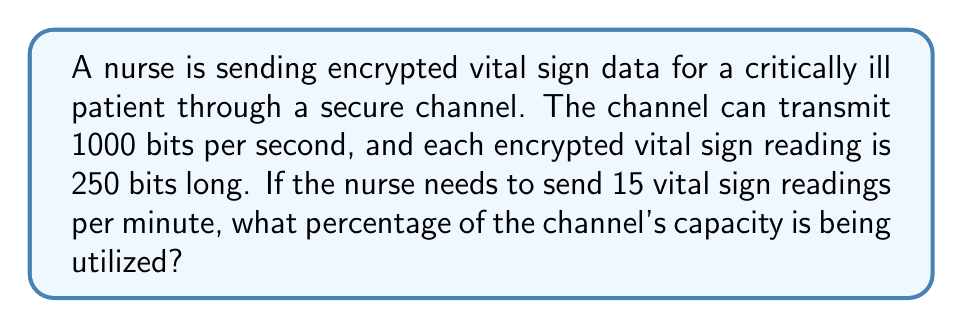Solve this math problem. Let's approach this step-by-step:

1. Calculate the number of bits transmitted per minute:
   - Each vital sign reading is 250 bits
   - 15 readings are sent per minute
   - Total bits per minute = $15 \times 250 = 3750$ bits/minute

2. Convert the channel capacity to bits per minute:
   - Channel capacity = 1000 bits/second
   - Bits per minute = $1000 \times 60 = 60000$ bits/minute

3. Calculate the percentage of channel capacity used:
   $$\text{Percentage} = \frac{\text{Bits transmitted}}{\text{Channel capacity}} \times 100\%$$
   $$= \frac{3750}{60000} \times 100\%$$
   $$= 0.0625 \times 100\%$$
   $$= 6.25\%$$

Therefore, the nurse is utilizing 6.25% of the channel's capacity to transmit the patient's vital sign data.
Answer: 6.25% 